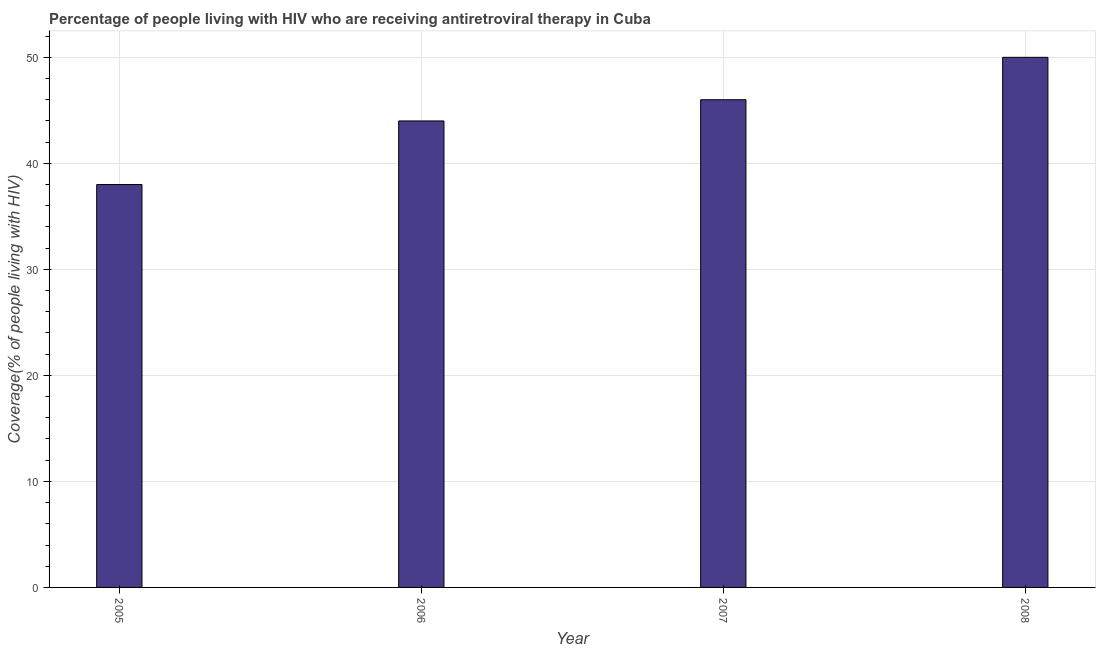Does the graph contain grids?
Keep it short and to the point. Yes. What is the title of the graph?
Offer a very short reply. Percentage of people living with HIV who are receiving antiretroviral therapy in Cuba. What is the label or title of the Y-axis?
Ensure brevity in your answer.  Coverage(% of people living with HIV). In which year was the antiretroviral therapy coverage minimum?
Ensure brevity in your answer.  2005. What is the sum of the antiretroviral therapy coverage?
Your answer should be very brief. 178. What is the median antiretroviral therapy coverage?
Provide a short and direct response. 45. In how many years, is the antiretroviral therapy coverage greater than 42 %?
Your answer should be very brief. 3. Do a majority of the years between 2008 and 2006 (inclusive) have antiretroviral therapy coverage greater than 40 %?
Give a very brief answer. Yes. What is the ratio of the antiretroviral therapy coverage in 2007 to that in 2008?
Offer a very short reply. 0.92. Is the antiretroviral therapy coverage in 2006 less than that in 2007?
Ensure brevity in your answer.  Yes. What is the difference between the highest and the lowest antiretroviral therapy coverage?
Your answer should be compact. 12. Are all the bars in the graph horizontal?
Your answer should be very brief. No. Are the values on the major ticks of Y-axis written in scientific E-notation?
Your answer should be compact. No. What is the Coverage(% of people living with HIV) in 2005?
Your response must be concise. 38. What is the Coverage(% of people living with HIV) in 2007?
Make the answer very short. 46. What is the difference between the Coverage(% of people living with HIV) in 2005 and 2006?
Give a very brief answer. -6. What is the difference between the Coverage(% of people living with HIV) in 2005 and 2007?
Your answer should be very brief. -8. What is the difference between the Coverage(% of people living with HIV) in 2006 and 2008?
Your answer should be very brief. -6. What is the difference between the Coverage(% of people living with HIV) in 2007 and 2008?
Give a very brief answer. -4. What is the ratio of the Coverage(% of people living with HIV) in 2005 to that in 2006?
Your answer should be compact. 0.86. What is the ratio of the Coverage(% of people living with HIV) in 2005 to that in 2007?
Ensure brevity in your answer.  0.83. What is the ratio of the Coverage(% of people living with HIV) in 2005 to that in 2008?
Your answer should be compact. 0.76. What is the ratio of the Coverage(% of people living with HIV) in 2006 to that in 2007?
Your response must be concise. 0.96. 